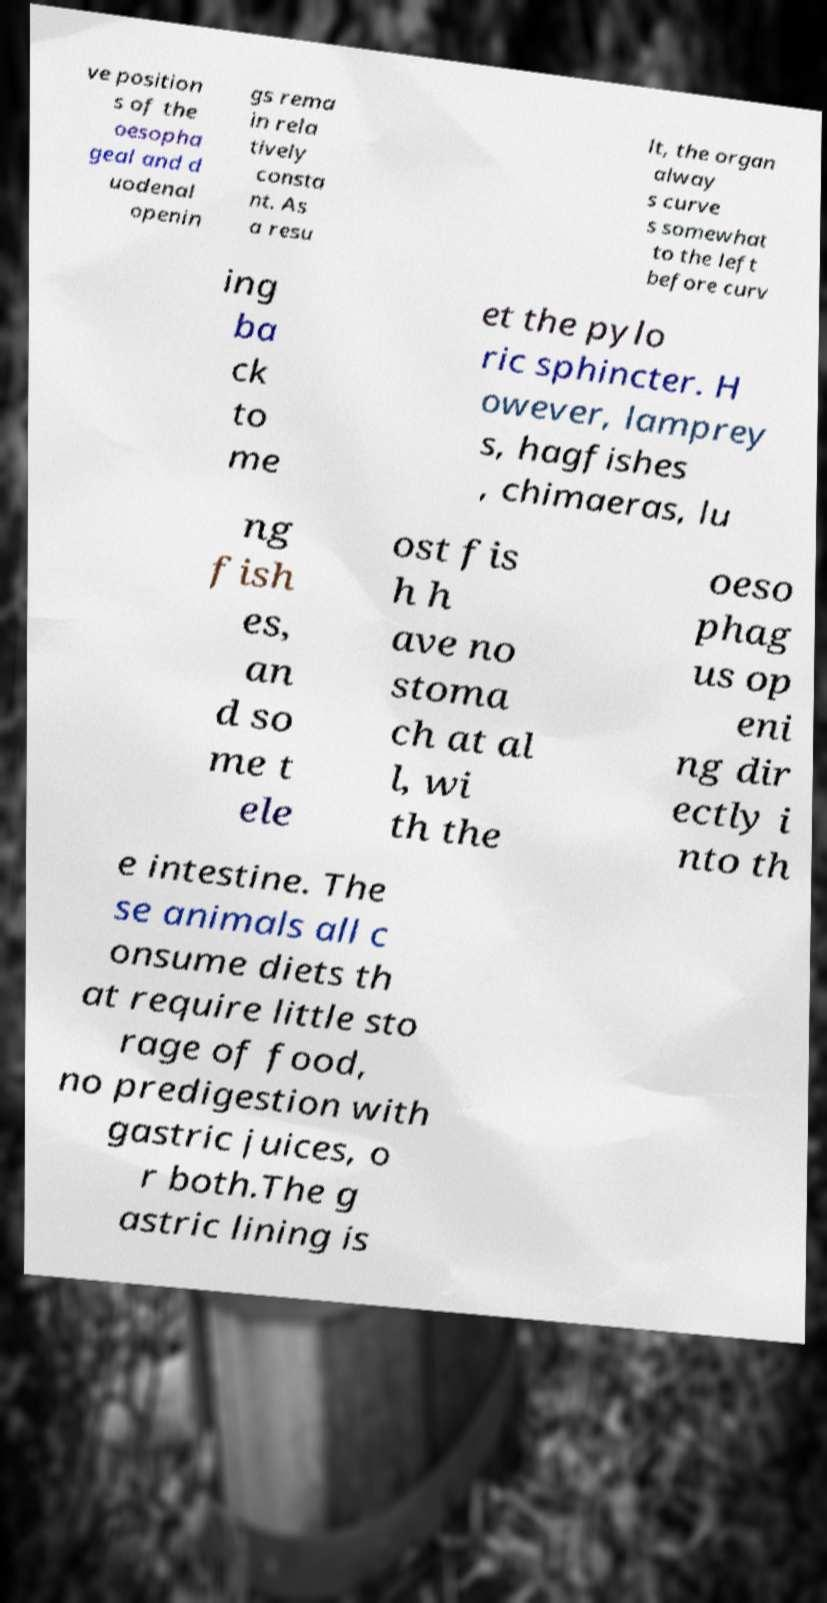Can you accurately transcribe the text from the provided image for me? ve position s of the oesopha geal and d uodenal openin gs rema in rela tively consta nt. As a resu lt, the organ alway s curve s somewhat to the left before curv ing ba ck to me et the pylo ric sphincter. H owever, lamprey s, hagfishes , chimaeras, lu ng fish es, an d so me t ele ost fis h h ave no stoma ch at al l, wi th the oeso phag us op eni ng dir ectly i nto th e intestine. The se animals all c onsume diets th at require little sto rage of food, no predigestion with gastric juices, o r both.The g astric lining is 